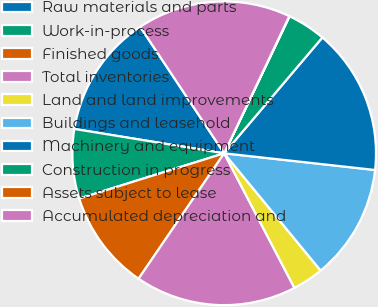<chart> <loc_0><loc_0><loc_500><loc_500><pie_chart><fcel>Raw materials and parts<fcel>Work-in-process<fcel>Finished goods<fcel>Total inventories<fcel>Land and land improvements<fcel>Buildings and leasehold<fcel>Machinery and equipment<fcel>Construction in progress<fcel>Assets subject to lease<fcel>Accumulated depreciation and<nl><fcel>13.11%<fcel>7.38%<fcel>10.65%<fcel>17.19%<fcel>3.3%<fcel>12.29%<fcel>15.56%<fcel>4.11%<fcel>0.03%<fcel>16.38%<nl></chart> 